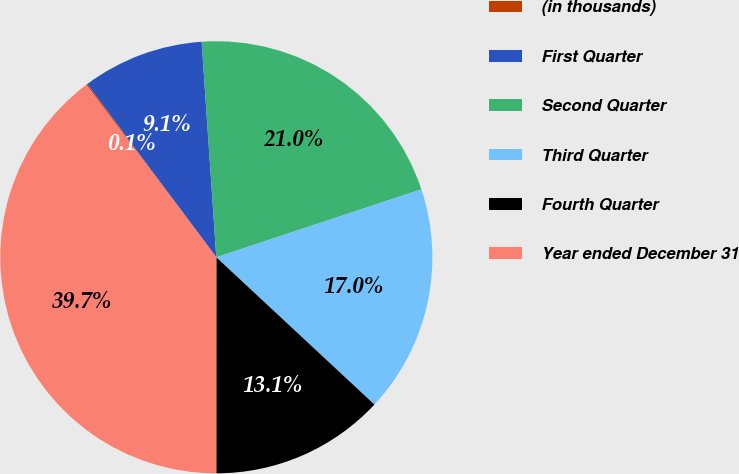Convert chart. <chart><loc_0><loc_0><loc_500><loc_500><pie_chart><fcel>(in thousands)<fcel>First Quarter<fcel>Second Quarter<fcel>Third Quarter<fcel>Fourth Quarter<fcel>Year ended December 31<nl><fcel>0.1%<fcel>9.1%<fcel>20.99%<fcel>17.03%<fcel>13.07%<fcel>39.72%<nl></chart> 